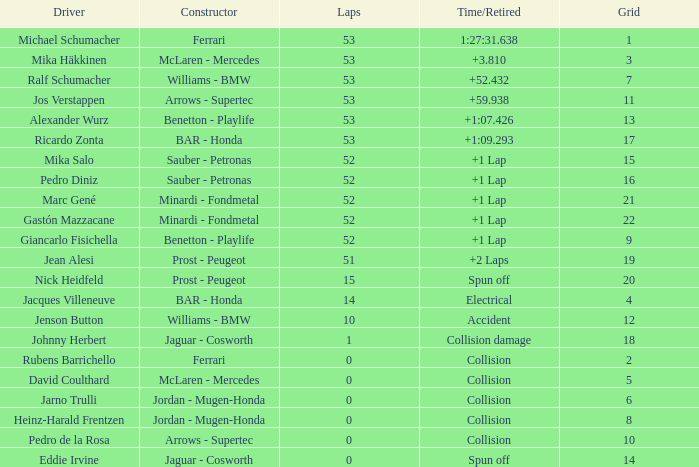What is the name of the driver with a grid less than 14, laps smaller than 53 and a Time/Retired of collision, and a Constructor of ferrari? Rubens Barrichello. 